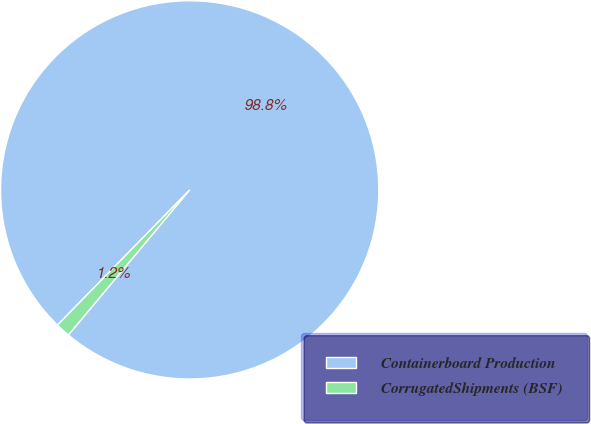Convert chart to OTSL. <chart><loc_0><loc_0><loc_500><loc_500><pie_chart><fcel>Containerboard Production<fcel>CorrugatedShipments (BSF)<nl><fcel>98.76%<fcel>1.24%<nl></chart> 